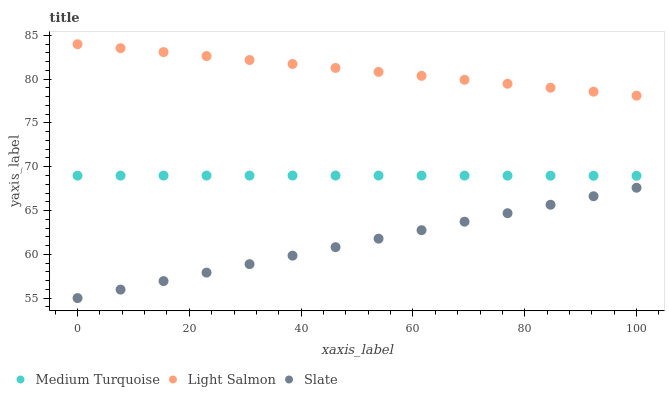Does Slate have the minimum area under the curve?
Answer yes or no. Yes. Does Light Salmon have the maximum area under the curve?
Answer yes or no. Yes. Does Medium Turquoise have the minimum area under the curve?
Answer yes or no. No. Does Medium Turquoise have the maximum area under the curve?
Answer yes or no. No. Is Slate the smoothest?
Answer yes or no. Yes. Is Medium Turquoise the roughest?
Answer yes or no. Yes. Is Medium Turquoise the smoothest?
Answer yes or no. No. Is Slate the roughest?
Answer yes or no. No. Does Slate have the lowest value?
Answer yes or no. Yes. Does Medium Turquoise have the lowest value?
Answer yes or no. No. Does Light Salmon have the highest value?
Answer yes or no. Yes. Does Medium Turquoise have the highest value?
Answer yes or no. No. Is Slate less than Medium Turquoise?
Answer yes or no. Yes. Is Medium Turquoise greater than Slate?
Answer yes or no. Yes. Does Slate intersect Medium Turquoise?
Answer yes or no. No. 